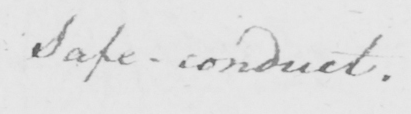What does this handwritten line say? Safe-conduct . 